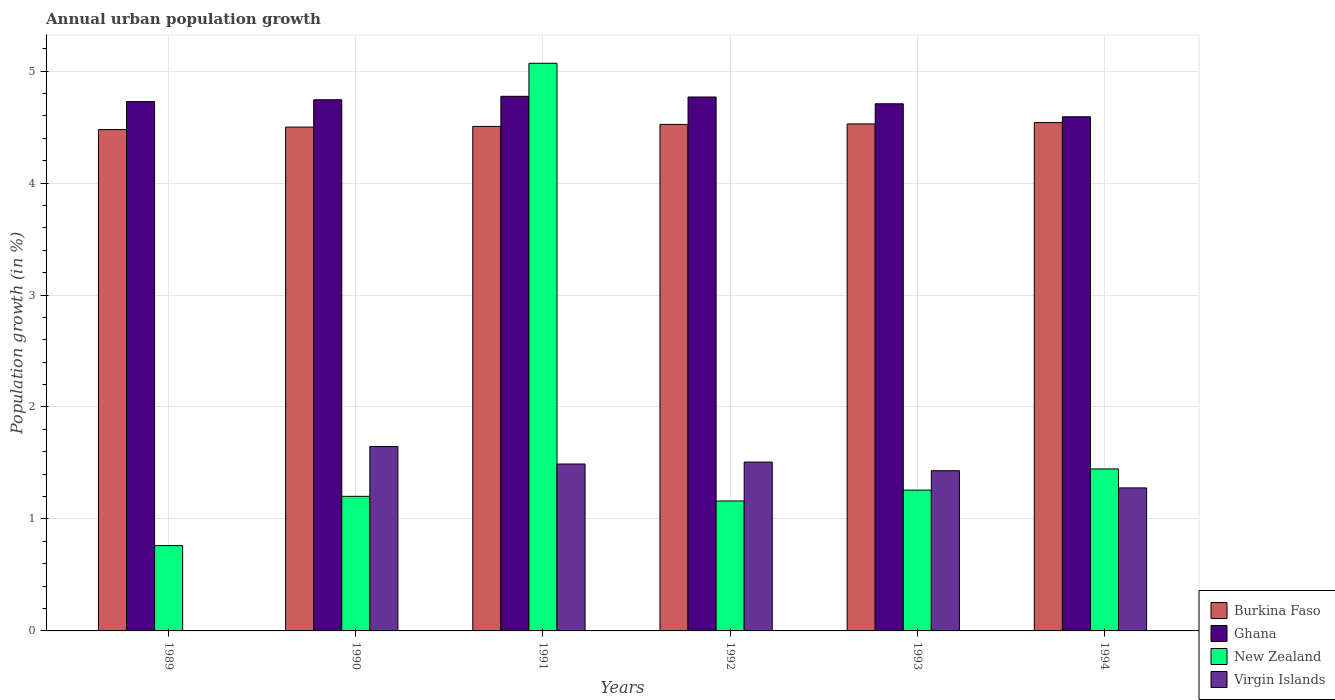How many different coloured bars are there?
Offer a very short reply. 4. How many groups of bars are there?
Provide a succinct answer. 6. How many bars are there on the 3rd tick from the right?
Offer a terse response. 4. What is the label of the 2nd group of bars from the left?
Offer a very short reply. 1990. In how many cases, is the number of bars for a given year not equal to the number of legend labels?
Provide a short and direct response. 1. What is the percentage of urban population growth in New Zealand in 1993?
Your answer should be very brief. 1.26. Across all years, what is the maximum percentage of urban population growth in Virgin Islands?
Your answer should be very brief. 1.65. Across all years, what is the minimum percentage of urban population growth in Burkina Faso?
Give a very brief answer. 4.48. What is the total percentage of urban population growth in Ghana in the graph?
Ensure brevity in your answer.  28.32. What is the difference between the percentage of urban population growth in Ghana in 1992 and that in 1994?
Offer a very short reply. 0.18. What is the difference between the percentage of urban population growth in Virgin Islands in 1994 and the percentage of urban population growth in Ghana in 1990?
Provide a succinct answer. -3.47. What is the average percentage of urban population growth in Ghana per year?
Provide a short and direct response. 4.72. In the year 1990, what is the difference between the percentage of urban population growth in Virgin Islands and percentage of urban population growth in Burkina Faso?
Provide a short and direct response. -2.85. What is the ratio of the percentage of urban population growth in New Zealand in 1989 to that in 1990?
Provide a succinct answer. 0.63. What is the difference between the highest and the second highest percentage of urban population growth in New Zealand?
Your answer should be very brief. 3.62. What is the difference between the highest and the lowest percentage of urban population growth in Virgin Islands?
Provide a short and direct response. 1.65. In how many years, is the percentage of urban population growth in New Zealand greater than the average percentage of urban population growth in New Zealand taken over all years?
Ensure brevity in your answer.  1. Is the sum of the percentage of urban population growth in Burkina Faso in 1993 and 1994 greater than the maximum percentage of urban population growth in Virgin Islands across all years?
Your answer should be compact. Yes. Is it the case that in every year, the sum of the percentage of urban population growth in Burkina Faso and percentage of urban population growth in Virgin Islands is greater than the sum of percentage of urban population growth in Ghana and percentage of urban population growth in New Zealand?
Provide a succinct answer. No. Are all the bars in the graph horizontal?
Your response must be concise. No. Where does the legend appear in the graph?
Your response must be concise. Bottom right. How many legend labels are there?
Your answer should be very brief. 4. How are the legend labels stacked?
Provide a succinct answer. Vertical. What is the title of the graph?
Give a very brief answer. Annual urban population growth. Does "Europe(all income levels)" appear as one of the legend labels in the graph?
Ensure brevity in your answer.  No. What is the label or title of the X-axis?
Your response must be concise. Years. What is the label or title of the Y-axis?
Make the answer very short. Population growth (in %). What is the Population growth (in %) of Burkina Faso in 1989?
Provide a short and direct response. 4.48. What is the Population growth (in %) of Ghana in 1989?
Your response must be concise. 4.73. What is the Population growth (in %) of New Zealand in 1989?
Ensure brevity in your answer.  0.76. What is the Population growth (in %) of Virgin Islands in 1989?
Provide a succinct answer. 0. What is the Population growth (in %) of Burkina Faso in 1990?
Offer a very short reply. 4.5. What is the Population growth (in %) of Ghana in 1990?
Give a very brief answer. 4.74. What is the Population growth (in %) in New Zealand in 1990?
Ensure brevity in your answer.  1.2. What is the Population growth (in %) of Virgin Islands in 1990?
Provide a succinct answer. 1.65. What is the Population growth (in %) of Burkina Faso in 1991?
Offer a very short reply. 4.51. What is the Population growth (in %) of Ghana in 1991?
Your response must be concise. 4.77. What is the Population growth (in %) of New Zealand in 1991?
Offer a very short reply. 5.07. What is the Population growth (in %) in Virgin Islands in 1991?
Keep it short and to the point. 1.49. What is the Population growth (in %) in Burkina Faso in 1992?
Provide a short and direct response. 4.52. What is the Population growth (in %) in Ghana in 1992?
Give a very brief answer. 4.77. What is the Population growth (in %) of New Zealand in 1992?
Offer a very short reply. 1.16. What is the Population growth (in %) in Virgin Islands in 1992?
Provide a short and direct response. 1.51. What is the Population growth (in %) of Burkina Faso in 1993?
Provide a succinct answer. 4.53. What is the Population growth (in %) of Ghana in 1993?
Offer a very short reply. 4.71. What is the Population growth (in %) in New Zealand in 1993?
Your response must be concise. 1.26. What is the Population growth (in %) of Virgin Islands in 1993?
Make the answer very short. 1.43. What is the Population growth (in %) in Burkina Faso in 1994?
Your answer should be compact. 4.54. What is the Population growth (in %) of Ghana in 1994?
Your answer should be very brief. 4.59. What is the Population growth (in %) of New Zealand in 1994?
Your answer should be compact. 1.45. What is the Population growth (in %) in Virgin Islands in 1994?
Make the answer very short. 1.28. Across all years, what is the maximum Population growth (in %) in Burkina Faso?
Ensure brevity in your answer.  4.54. Across all years, what is the maximum Population growth (in %) in Ghana?
Make the answer very short. 4.77. Across all years, what is the maximum Population growth (in %) in New Zealand?
Provide a succinct answer. 5.07. Across all years, what is the maximum Population growth (in %) in Virgin Islands?
Your response must be concise. 1.65. Across all years, what is the minimum Population growth (in %) in Burkina Faso?
Provide a succinct answer. 4.48. Across all years, what is the minimum Population growth (in %) in Ghana?
Your response must be concise. 4.59. Across all years, what is the minimum Population growth (in %) in New Zealand?
Ensure brevity in your answer.  0.76. What is the total Population growth (in %) of Burkina Faso in the graph?
Your answer should be very brief. 27.08. What is the total Population growth (in %) of Ghana in the graph?
Give a very brief answer. 28.32. What is the total Population growth (in %) in New Zealand in the graph?
Give a very brief answer. 10.9. What is the total Population growth (in %) of Virgin Islands in the graph?
Your response must be concise. 7.35. What is the difference between the Population growth (in %) of Burkina Faso in 1989 and that in 1990?
Ensure brevity in your answer.  -0.02. What is the difference between the Population growth (in %) in Ghana in 1989 and that in 1990?
Keep it short and to the point. -0.02. What is the difference between the Population growth (in %) in New Zealand in 1989 and that in 1990?
Make the answer very short. -0.44. What is the difference between the Population growth (in %) of Burkina Faso in 1989 and that in 1991?
Your response must be concise. -0.03. What is the difference between the Population growth (in %) of Ghana in 1989 and that in 1991?
Your answer should be very brief. -0.05. What is the difference between the Population growth (in %) of New Zealand in 1989 and that in 1991?
Give a very brief answer. -4.31. What is the difference between the Population growth (in %) in Burkina Faso in 1989 and that in 1992?
Give a very brief answer. -0.05. What is the difference between the Population growth (in %) in Ghana in 1989 and that in 1992?
Provide a succinct answer. -0.04. What is the difference between the Population growth (in %) in New Zealand in 1989 and that in 1992?
Offer a very short reply. -0.4. What is the difference between the Population growth (in %) of Burkina Faso in 1989 and that in 1993?
Your response must be concise. -0.05. What is the difference between the Population growth (in %) of Ghana in 1989 and that in 1993?
Offer a very short reply. 0.02. What is the difference between the Population growth (in %) in New Zealand in 1989 and that in 1993?
Make the answer very short. -0.5. What is the difference between the Population growth (in %) in Burkina Faso in 1989 and that in 1994?
Provide a short and direct response. -0.06. What is the difference between the Population growth (in %) in Ghana in 1989 and that in 1994?
Your answer should be compact. 0.14. What is the difference between the Population growth (in %) in New Zealand in 1989 and that in 1994?
Your answer should be compact. -0.68. What is the difference between the Population growth (in %) in Burkina Faso in 1990 and that in 1991?
Ensure brevity in your answer.  -0.01. What is the difference between the Population growth (in %) in Ghana in 1990 and that in 1991?
Provide a succinct answer. -0.03. What is the difference between the Population growth (in %) in New Zealand in 1990 and that in 1991?
Give a very brief answer. -3.87. What is the difference between the Population growth (in %) of Virgin Islands in 1990 and that in 1991?
Keep it short and to the point. 0.16. What is the difference between the Population growth (in %) in Burkina Faso in 1990 and that in 1992?
Give a very brief answer. -0.02. What is the difference between the Population growth (in %) in Ghana in 1990 and that in 1992?
Provide a short and direct response. -0.02. What is the difference between the Population growth (in %) in New Zealand in 1990 and that in 1992?
Give a very brief answer. 0.04. What is the difference between the Population growth (in %) in Virgin Islands in 1990 and that in 1992?
Give a very brief answer. 0.14. What is the difference between the Population growth (in %) of Burkina Faso in 1990 and that in 1993?
Make the answer very short. -0.03. What is the difference between the Population growth (in %) in Ghana in 1990 and that in 1993?
Offer a terse response. 0.04. What is the difference between the Population growth (in %) in New Zealand in 1990 and that in 1993?
Ensure brevity in your answer.  -0.06. What is the difference between the Population growth (in %) of Virgin Islands in 1990 and that in 1993?
Provide a succinct answer. 0.22. What is the difference between the Population growth (in %) in Burkina Faso in 1990 and that in 1994?
Provide a succinct answer. -0.04. What is the difference between the Population growth (in %) of Ghana in 1990 and that in 1994?
Provide a short and direct response. 0.15. What is the difference between the Population growth (in %) of New Zealand in 1990 and that in 1994?
Your response must be concise. -0.24. What is the difference between the Population growth (in %) in Virgin Islands in 1990 and that in 1994?
Ensure brevity in your answer.  0.37. What is the difference between the Population growth (in %) of Burkina Faso in 1991 and that in 1992?
Ensure brevity in your answer.  -0.02. What is the difference between the Population growth (in %) of Ghana in 1991 and that in 1992?
Offer a terse response. 0.01. What is the difference between the Population growth (in %) in New Zealand in 1991 and that in 1992?
Make the answer very short. 3.91. What is the difference between the Population growth (in %) of Virgin Islands in 1991 and that in 1992?
Your response must be concise. -0.02. What is the difference between the Population growth (in %) in Burkina Faso in 1991 and that in 1993?
Offer a terse response. -0.02. What is the difference between the Population growth (in %) of Ghana in 1991 and that in 1993?
Your answer should be very brief. 0.07. What is the difference between the Population growth (in %) in New Zealand in 1991 and that in 1993?
Offer a terse response. 3.81. What is the difference between the Population growth (in %) of Virgin Islands in 1991 and that in 1993?
Keep it short and to the point. 0.06. What is the difference between the Population growth (in %) in Burkina Faso in 1991 and that in 1994?
Give a very brief answer. -0.03. What is the difference between the Population growth (in %) of Ghana in 1991 and that in 1994?
Your response must be concise. 0.18. What is the difference between the Population growth (in %) in New Zealand in 1991 and that in 1994?
Offer a terse response. 3.62. What is the difference between the Population growth (in %) of Virgin Islands in 1991 and that in 1994?
Ensure brevity in your answer.  0.21. What is the difference between the Population growth (in %) of Burkina Faso in 1992 and that in 1993?
Your answer should be very brief. -0. What is the difference between the Population growth (in %) of Ghana in 1992 and that in 1993?
Your response must be concise. 0.06. What is the difference between the Population growth (in %) of New Zealand in 1992 and that in 1993?
Your response must be concise. -0.1. What is the difference between the Population growth (in %) in Virgin Islands in 1992 and that in 1993?
Offer a terse response. 0.08. What is the difference between the Population growth (in %) in Burkina Faso in 1992 and that in 1994?
Your response must be concise. -0.02. What is the difference between the Population growth (in %) in Ghana in 1992 and that in 1994?
Offer a very short reply. 0.18. What is the difference between the Population growth (in %) in New Zealand in 1992 and that in 1994?
Keep it short and to the point. -0.29. What is the difference between the Population growth (in %) in Virgin Islands in 1992 and that in 1994?
Your answer should be very brief. 0.23. What is the difference between the Population growth (in %) in Burkina Faso in 1993 and that in 1994?
Ensure brevity in your answer.  -0.01. What is the difference between the Population growth (in %) in Ghana in 1993 and that in 1994?
Provide a short and direct response. 0.12. What is the difference between the Population growth (in %) in New Zealand in 1993 and that in 1994?
Your answer should be very brief. -0.19. What is the difference between the Population growth (in %) in Virgin Islands in 1993 and that in 1994?
Make the answer very short. 0.15. What is the difference between the Population growth (in %) in Burkina Faso in 1989 and the Population growth (in %) in Ghana in 1990?
Your response must be concise. -0.27. What is the difference between the Population growth (in %) of Burkina Faso in 1989 and the Population growth (in %) of New Zealand in 1990?
Provide a short and direct response. 3.28. What is the difference between the Population growth (in %) in Burkina Faso in 1989 and the Population growth (in %) in Virgin Islands in 1990?
Offer a very short reply. 2.83. What is the difference between the Population growth (in %) in Ghana in 1989 and the Population growth (in %) in New Zealand in 1990?
Your answer should be very brief. 3.53. What is the difference between the Population growth (in %) of Ghana in 1989 and the Population growth (in %) of Virgin Islands in 1990?
Provide a succinct answer. 3.08. What is the difference between the Population growth (in %) in New Zealand in 1989 and the Population growth (in %) in Virgin Islands in 1990?
Your answer should be very brief. -0.88. What is the difference between the Population growth (in %) of Burkina Faso in 1989 and the Population growth (in %) of Ghana in 1991?
Ensure brevity in your answer.  -0.3. What is the difference between the Population growth (in %) in Burkina Faso in 1989 and the Population growth (in %) in New Zealand in 1991?
Offer a terse response. -0.59. What is the difference between the Population growth (in %) of Burkina Faso in 1989 and the Population growth (in %) of Virgin Islands in 1991?
Make the answer very short. 2.99. What is the difference between the Population growth (in %) of Ghana in 1989 and the Population growth (in %) of New Zealand in 1991?
Make the answer very short. -0.34. What is the difference between the Population growth (in %) of Ghana in 1989 and the Population growth (in %) of Virgin Islands in 1991?
Your answer should be compact. 3.24. What is the difference between the Population growth (in %) in New Zealand in 1989 and the Population growth (in %) in Virgin Islands in 1991?
Make the answer very short. -0.73. What is the difference between the Population growth (in %) of Burkina Faso in 1989 and the Population growth (in %) of Ghana in 1992?
Ensure brevity in your answer.  -0.29. What is the difference between the Population growth (in %) of Burkina Faso in 1989 and the Population growth (in %) of New Zealand in 1992?
Your answer should be compact. 3.32. What is the difference between the Population growth (in %) in Burkina Faso in 1989 and the Population growth (in %) in Virgin Islands in 1992?
Offer a terse response. 2.97. What is the difference between the Population growth (in %) in Ghana in 1989 and the Population growth (in %) in New Zealand in 1992?
Make the answer very short. 3.57. What is the difference between the Population growth (in %) of Ghana in 1989 and the Population growth (in %) of Virgin Islands in 1992?
Keep it short and to the point. 3.22. What is the difference between the Population growth (in %) in New Zealand in 1989 and the Population growth (in %) in Virgin Islands in 1992?
Your response must be concise. -0.75. What is the difference between the Population growth (in %) of Burkina Faso in 1989 and the Population growth (in %) of Ghana in 1993?
Offer a very short reply. -0.23. What is the difference between the Population growth (in %) in Burkina Faso in 1989 and the Population growth (in %) in New Zealand in 1993?
Offer a very short reply. 3.22. What is the difference between the Population growth (in %) in Burkina Faso in 1989 and the Population growth (in %) in Virgin Islands in 1993?
Provide a short and direct response. 3.05. What is the difference between the Population growth (in %) in Ghana in 1989 and the Population growth (in %) in New Zealand in 1993?
Give a very brief answer. 3.47. What is the difference between the Population growth (in %) in Ghana in 1989 and the Population growth (in %) in Virgin Islands in 1993?
Provide a short and direct response. 3.3. What is the difference between the Population growth (in %) in New Zealand in 1989 and the Population growth (in %) in Virgin Islands in 1993?
Your response must be concise. -0.67. What is the difference between the Population growth (in %) in Burkina Faso in 1989 and the Population growth (in %) in Ghana in 1994?
Provide a short and direct response. -0.11. What is the difference between the Population growth (in %) of Burkina Faso in 1989 and the Population growth (in %) of New Zealand in 1994?
Your response must be concise. 3.03. What is the difference between the Population growth (in %) in Burkina Faso in 1989 and the Population growth (in %) in Virgin Islands in 1994?
Make the answer very short. 3.2. What is the difference between the Population growth (in %) of Ghana in 1989 and the Population growth (in %) of New Zealand in 1994?
Provide a succinct answer. 3.28. What is the difference between the Population growth (in %) of Ghana in 1989 and the Population growth (in %) of Virgin Islands in 1994?
Offer a terse response. 3.45. What is the difference between the Population growth (in %) of New Zealand in 1989 and the Population growth (in %) of Virgin Islands in 1994?
Provide a short and direct response. -0.52. What is the difference between the Population growth (in %) of Burkina Faso in 1990 and the Population growth (in %) of Ghana in 1991?
Provide a succinct answer. -0.27. What is the difference between the Population growth (in %) in Burkina Faso in 1990 and the Population growth (in %) in New Zealand in 1991?
Offer a terse response. -0.57. What is the difference between the Population growth (in %) of Burkina Faso in 1990 and the Population growth (in %) of Virgin Islands in 1991?
Provide a short and direct response. 3.01. What is the difference between the Population growth (in %) of Ghana in 1990 and the Population growth (in %) of New Zealand in 1991?
Offer a terse response. -0.33. What is the difference between the Population growth (in %) of Ghana in 1990 and the Population growth (in %) of Virgin Islands in 1991?
Your response must be concise. 3.25. What is the difference between the Population growth (in %) in New Zealand in 1990 and the Population growth (in %) in Virgin Islands in 1991?
Make the answer very short. -0.29. What is the difference between the Population growth (in %) of Burkina Faso in 1990 and the Population growth (in %) of Ghana in 1992?
Offer a terse response. -0.27. What is the difference between the Population growth (in %) of Burkina Faso in 1990 and the Population growth (in %) of New Zealand in 1992?
Provide a succinct answer. 3.34. What is the difference between the Population growth (in %) of Burkina Faso in 1990 and the Population growth (in %) of Virgin Islands in 1992?
Your answer should be compact. 2.99. What is the difference between the Population growth (in %) of Ghana in 1990 and the Population growth (in %) of New Zealand in 1992?
Give a very brief answer. 3.58. What is the difference between the Population growth (in %) of Ghana in 1990 and the Population growth (in %) of Virgin Islands in 1992?
Provide a succinct answer. 3.24. What is the difference between the Population growth (in %) in New Zealand in 1990 and the Population growth (in %) in Virgin Islands in 1992?
Your response must be concise. -0.31. What is the difference between the Population growth (in %) of Burkina Faso in 1990 and the Population growth (in %) of Ghana in 1993?
Ensure brevity in your answer.  -0.21. What is the difference between the Population growth (in %) in Burkina Faso in 1990 and the Population growth (in %) in New Zealand in 1993?
Offer a very short reply. 3.24. What is the difference between the Population growth (in %) in Burkina Faso in 1990 and the Population growth (in %) in Virgin Islands in 1993?
Your answer should be very brief. 3.07. What is the difference between the Population growth (in %) in Ghana in 1990 and the Population growth (in %) in New Zealand in 1993?
Keep it short and to the point. 3.49. What is the difference between the Population growth (in %) of Ghana in 1990 and the Population growth (in %) of Virgin Islands in 1993?
Ensure brevity in your answer.  3.31. What is the difference between the Population growth (in %) in New Zealand in 1990 and the Population growth (in %) in Virgin Islands in 1993?
Give a very brief answer. -0.23. What is the difference between the Population growth (in %) in Burkina Faso in 1990 and the Population growth (in %) in Ghana in 1994?
Make the answer very short. -0.09. What is the difference between the Population growth (in %) in Burkina Faso in 1990 and the Population growth (in %) in New Zealand in 1994?
Provide a succinct answer. 3.05. What is the difference between the Population growth (in %) of Burkina Faso in 1990 and the Population growth (in %) of Virgin Islands in 1994?
Provide a succinct answer. 3.22. What is the difference between the Population growth (in %) in Ghana in 1990 and the Population growth (in %) in New Zealand in 1994?
Your answer should be very brief. 3.3. What is the difference between the Population growth (in %) of Ghana in 1990 and the Population growth (in %) of Virgin Islands in 1994?
Ensure brevity in your answer.  3.47. What is the difference between the Population growth (in %) in New Zealand in 1990 and the Population growth (in %) in Virgin Islands in 1994?
Your response must be concise. -0.08. What is the difference between the Population growth (in %) of Burkina Faso in 1991 and the Population growth (in %) of Ghana in 1992?
Provide a short and direct response. -0.26. What is the difference between the Population growth (in %) in Burkina Faso in 1991 and the Population growth (in %) in New Zealand in 1992?
Ensure brevity in your answer.  3.35. What is the difference between the Population growth (in %) of Burkina Faso in 1991 and the Population growth (in %) of Virgin Islands in 1992?
Ensure brevity in your answer.  3. What is the difference between the Population growth (in %) in Ghana in 1991 and the Population growth (in %) in New Zealand in 1992?
Your answer should be very brief. 3.61. What is the difference between the Population growth (in %) of Ghana in 1991 and the Population growth (in %) of Virgin Islands in 1992?
Provide a short and direct response. 3.27. What is the difference between the Population growth (in %) of New Zealand in 1991 and the Population growth (in %) of Virgin Islands in 1992?
Offer a very short reply. 3.56. What is the difference between the Population growth (in %) of Burkina Faso in 1991 and the Population growth (in %) of Ghana in 1993?
Keep it short and to the point. -0.2. What is the difference between the Population growth (in %) in Burkina Faso in 1991 and the Population growth (in %) in New Zealand in 1993?
Offer a very short reply. 3.25. What is the difference between the Population growth (in %) of Burkina Faso in 1991 and the Population growth (in %) of Virgin Islands in 1993?
Your response must be concise. 3.07. What is the difference between the Population growth (in %) in Ghana in 1991 and the Population growth (in %) in New Zealand in 1993?
Your answer should be compact. 3.52. What is the difference between the Population growth (in %) of Ghana in 1991 and the Population growth (in %) of Virgin Islands in 1993?
Your answer should be very brief. 3.34. What is the difference between the Population growth (in %) in New Zealand in 1991 and the Population growth (in %) in Virgin Islands in 1993?
Provide a succinct answer. 3.64. What is the difference between the Population growth (in %) in Burkina Faso in 1991 and the Population growth (in %) in Ghana in 1994?
Provide a succinct answer. -0.09. What is the difference between the Population growth (in %) in Burkina Faso in 1991 and the Population growth (in %) in New Zealand in 1994?
Keep it short and to the point. 3.06. What is the difference between the Population growth (in %) in Burkina Faso in 1991 and the Population growth (in %) in Virgin Islands in 1994?
Give a very brief answer. 3.23. What is the difference between the Population growth (in %) in Ghana in 1991 and the Population growth (in %) in New Zealand in 1994?
Your answer should be compact. 3.33. What is the difference between the Population growth (in %) in Ghana in 1991 and the Population growth (in %) in Virgin Islands in 1994?
Keep it short and to the point. 3.5. What is the difference between the Population growth (in %) of New Zealand in 1991 and the Population growth (in %) of Virgin Islands in 1994?
Ensure brevity in your answer.  3.79. What is the difference between the Population growth (in %) of Burkina Faso in 1992 and the Population growth (in %) of Ghana in 1993?
Ensure brevity in your answer.  -0.18. What is the difference between the Population growth (in %) of Burkina Faso in 1992 and the Population growth (in %) of New Zealand in 1993?
Provide a short and direct response. 3.27. What is the difference between the Population growth (in %) of Burkina Faso in 1992 and the Population growth (in %) of Virgin Islands in 1993?
Keep it short and to the point. 3.09. What is the difference between the Population growth (in %) of Ghana in 1992 and the Population growth (in %) of New Zealand in 1993?
Your response must be concise. 3.51. What is the difference between the Population growth (in %) in Ghana in 1992 and the Population growth (in %) in Virgin Islands in 1993?
Your response must be concise. 3.34. What is the difference between the Population growth (in %) of New Zealand in 1992 and the Population growth (in %) of Virgin Islands in 1993?
Give a very brief answer. -0.27. What is the difference between the Population growth (in %) of Burkina Faso in 1992 and the Population growth (in %) of Ghana in 1994?
Provide a succinct answer. -0.07. What is the difference between the Population growth (in %) of Burkina Faso in 1992 and the Population growth (in %) of New Zealand in 1994?
Offer a terse response. 3.08. What is the difference between the Population growth (in %) in Burkina Faso in 1992 and the Population growth (in %) in Virgin Islands in 1994?
Provide a succinct answer. 3.25. What is the difference between the Population growth (in %) of Ghana in 1992 and the Population growth (in %) of New Zealand in 1994?
Make the answer very short. 3.32. What is the difference between the Population growth (in %) in Ghana in 1992 and the Population growth (in %) in Virgin Islands in 1994?
Your response must be concise. 3.49. What is the difference between the Population growth (in %) in New Zealand in 1992 and the Population growth (in %) in Virgin Islands in 1994?
Offer a very short reply. -0.12. What is the difference between the Population growth (in %) in Burkina Faso in 1993 and the Population growth (in %) in Ghana in 1994?
Your response must be concise. -0.06. What is the difference between the Population growth (in %) in Burkina Faso in 1993 and the Population growth (in %) in New Zealand in 1994?
Offer a very short reply. 3.08. What is the difference between the Population growth (in %) of Burkina Faso in 1993 and the Population growth (in %) of Virgin Islands in 1994?
Your answer should be compact. 3.25. What is the difference between the Population growth (in %) of Ghana in 1993 and the Population growth (in %) of New Zealand in 1994?
Make the answer very short. 3.26. What is the difference between the Population growth (in %) of Ghana in 1993 and the Population growth (in %) of Virgin Islands in 1994?
Your answer should be very brief. 3.43. What is the difference between the Population growth (in %) of New Zealand in 1993 and the Population growth (in %) of Virgin Islands in 1994?
Give a very brief answer. -0.02. What is the average Population growth (in %) of Burkina Faso per year?
Ensure brevity in your answer.  4.51. What is the average Population growth (in %) of Ghana per year?
Offer a very short reply. 4.72. What is the average Population growth (in %) in New Zealand per year?
Make the answer very short. 1.82. What is the average Population growth (in %) in Virgin Islands per year?
Ensure brevity in your answer.  1.23. In the year 1989, what is the difference between the Population growth (in %) in Burkina Faso and Population growth (in %) in Ghana?
Offer a very short reply. -0.25. In the year 1989, what is the difference between the Population growth (in %) of Burkina Faso and Population growth (in %) of New Zealand?
Keep it short and to the point. 3.72. In the year 1989, what is the difference between the Population growth (in %) of Ghana and Population growth (in %) of New Zealand?
Provide a succinct answer. 3.97. In the year 1990, what is the difference between the Population growth (in %) in Burkina Faso and Population growth (in %) in Ghana?
Provide a short and direct response. -0.24. In the year 1990, what is the difference between the Population growth (in %) of Burkina Faso and Population growth (in %) of New Zealand?
Provide a short and direct response. 3.3. In the year 1990, what is the difference between the Population growth (in %) of Burkina Faso and Population growth (in %) of Virgin Islands?
Keep it short and to the point. 2.85. In the year 1990, what is the difference between the Population growth (in %) in Ghana and Population growth (in %) in New Zealand?
Your response must be concise. 3.54. In the year 1990, what is the difference between the Population growth (in %) of Ghana and Population growth (in %) of Virgin Islands?
Provide a short and direct response. 3.1. In the year 1990, what is the difference between the Population growth (in %) in New Zealand and Population growth (in %) in Virgin Islands?
Offer a very short reply. -0.44. In the year 1991, what is the difference between the Population growth (in %) of Burkina Faso and Population growth (in %) of Ghana?
Give a very brief answer. -0.27. In the year 1991, what is the difference between the Population growth (in %) of Burkina Faso and Population growth (in %) of New Zealand?
Offer a very short reply. -0.56. In the year 1991, what is the difference between the Population growth (in %) in Burkina Faso and Population growth (in %) in Virgin Islands?
Give a very brief answer. 3.02. In the year 1991, what is the difference between the Population growth (in %) of Ghana and Population growth (in %) of New Zealand?
Offer a terse response. -0.3. In the year 1991, what is the difference between the Population growth (in %) of Ghana and Population growth (in %) of Virgin Islands?
Provide a succinct answer. 3.28. In the year 1991, what is the difference between the Population growth (in %) of New Zealand and Population growth (in %) of Virgin Islands?
Your answer should be compact. 3.58. In the year 1992, what is the difference between the Population growth (in %) of Burkina Faso and Population growth (in %) of Ghana?
Your answer should be very brief. -0.24. In the year 1992, what is the difference between the Population growth (in %) in Burkina Faso and Population growth (in %) in New Zealand?
Your response must be concise. 3.36. In the year 1992, what is the difference between the Population growth (in %) of Burkina Faso and Population growth (in %) of Virgin Islands?
Ensure brevity in your answer.  3.02. In the year 1992, what is the difference between the Population growth (in %) of Ghana and Population growth (in %) of New Zealand?
Your answer should be very brief. 3.61. In the year 1992, what is the difference between the Population growth (in %) in Ghana and Population growth (in %) in Virgin Islands?
Offer a very short reply. 3.26. In the year 1992, what is the difference between the Population growth (in %) in New Zealand and Population growth (in %) in Virgin Islands?
Give a very brief answer. -0.35. In the year 1993, what is the difference between the Population growth (in %) in Burkina Faso and Population growth (in %) in Ghana?
Make the answer very short. -0.18. In the year 1993, what is the difference between the Population growth (in %) in Burkina Faso and Population growth (in %) in New Zealand?
Offer a terse response. 3.27. In the year 1993, what is the difference between the Population growth (in %) of Burkina Faso and Population growth (in %) of Virgin Islands?
Your response must be concise. 3.1. In the year 1993, what is the difference between the Population growth (in %) of Ghana and Population growth (in %) of New Zealand?
Keep it short and to the point. 3.45. In the year 1993, what is the difference between the Population growth (in %) of Ghana and Population growth (in %) of Virgin Islands?
Offer a very short reply. 3.28. In the year 1993, what is the difference between the Population growth (in %) of New Zealand and Population growth (in %) of Virgin Islands?
Your response must be concise. -0.17. In the year 1994, what is the difference between the Population growth (in %) in Burkina Faso and Population growth (in %) in Ghana?
Give a very brief answer. -0.05. In the year 1994, what is the difference between the Population growth (in %) of Burkina Faso and Population growth (in %) of New Zealand?
Offer a terse response. 3.09. In the year 1994, what is the difference between the Population growth (in %) in Burkina Faso and Population growth (in %) in Virgin Islands?
Offer a terse response. 3.26. In the year 1994, what is the difference between the Population growth (in %) of Ghana and Population growth (in %) of New Zealand?
Ensure brevity in your answer.  3.15. In the year 1994, what is the difference between the Population growth (in %) in Ghana and Population growth (in %) in Virgin Islands?
Your answer should be very brief. 3.31. In the year 1994, what is the difference between the Population growth (in %) of New Zealand and Population growth (in %) of Virgin Islands?
Offer a very short reply. 0.17. What is the ratio of the Population growth (in %) in New Zealand in 1989 to that in 1990?
Provide a succinct answer. 0.63. What is the ratio of the Population growth (in %) in Burkina Faso in 1989 to that in 1991?
Offer a terse response. 0.99. What is the ratio of the Population growth (in %) in Ghana in 1989 to that in 1991?
Your response must be concise. 0.99. What is the ratio of the Population growth (in %) of New Zealand in 1989 to that in 1991?
Make the answer very short. 0.15. What is the ratio of the Population growth (in %) of Ghana in 1989 to that in 1992?
Offer a very short reply. 0.99. What is the ratio of the Population growth (in %) of New Zealand in 1989 to that in 1992?
Your response must be concise. 0.66. What is the ratio of the Population growth (in %) of Burkina Faso in 1989 to that in 1993?
Provide a short and direct response. 0.99. What is the ratio of the Population growth (in %) in Ghana in 1989 to that in 1993?
Give a very brief answer. 1. What is the ratio of the Population growth (in %) in New Zealand in 1989 to that in 1993?
Give a very brief answer. 0.61. What is the ratio of the Population growth (in %) of Burkina Faso in 1989 to that in 1994?
Provide a short and direct response. 0.99. What is the ratio of the Population growth (in %) of Ghana in 1989 to that in 1994?
Your response must be concise. 1.03. What is the ratio of the Population growth (in %) in New Zealand in 1989 to that in 1994?
Ensure brevity in your answer.  0.53. What is the ratio of the Population growth (in %) in Burkina Faso in 1990 to that in 1991?
Your answer should be very brief. 1. What is the ratio of the Population growth (in %) in Ghana in 1990 to that in 1991?
Offer a very short reply. 0.99. What is the ratio of the Population growth (in %) of New Zealand in 1990 to that in 1991?
Make the answer very short. 0.24. What is the ratio of the Population growth (in %) of Virgin Islands in 1990 to that in 1991?
Provide a succinct answer. 1.1. What is the ratio of the Population growth (in %) of Burkina Faso in 1990 to that in 1992?
Provide a succinct answer. 0.99. What is the ratio of the Population growth (in %) in New Zealand in 1990 to that in 1992?
Offer a terse response. 1.04. What is the ratio of the Population growth (in %) of Virgin Islands in 1990 to that in 1992?
Give a very brief answer. 1.09. What is the ratio of the Population growth (in %) in Burkina Faso in 1990 to that in 1993?
Your answer should be very brief. 0.99. What is the ratio of the Population growth (in %) of Ghana in 1990 to that in 1993?
Make the answer very short. 1.01. What is the ratio of the Population growth (in %) in New Zealand in 1990 to that in 1993?
Make the answer very short. 0.96. What is the ratio of the Population growth (in %) of Virgin Islands in 1990 to that in 1993?
Your response must be concise. 1.15. What is the ratio of the Population growth (in %) of Ghana in 1990 to that in 1994?
Your response must be concise. 1.03. What is the ratio of the Population growth (in %) of New Zealand in 1990 to that in 1994?
Give a very brief answer. 0.83. What is the ratio of the Population growth (in %) of Virgin Islands in 1990 to that in 1994?
Your response must be concise. 1.29. What is the ratio of the Population growth (in %) of Burkina Faso in 1991 to that in 1992?
Provide a short and direct response. 1. What is the ratio of the Population growth (in %) of New Zealand in 1991 to that in 1992?
Your answer should be very brief. 4.37. What is the ratio of the Population growth (in %) of Virgin Islands in 1991 to that in 1992?
Provide a succinct answer. 0.99. What is the ratio of the Population growth (in %) in Burkina Faso in 1991 to that in 1993?
Your response must be concise. 1. What is the ratio of the Population growth (in %) of Ghana in 1991 to that in 1993?
Ensure brevity in your answer.  1.01. What is the ratio of the Population growth (in %) in New Zealand in 1991 to that in 1993?
Ensure brevity in your answer.  4.03. What is the ratio of the Population growth (in %) of Virgin Islands in 1991 to that in 1993?
Provide a succinct answer. 1.04. What is the ratio of the Population growth (in %) of Ghana in 1991 to that in 1994?
Your answer should be compact. 1.04. What is the ratio of the Population growth (in %) in New Zealand in 1991 to that in 1994?
Offer a terse response. 3.5. What is the ratio of the Population growth (in %) in Virgin Islands in 1991 to that in 1994?
Offer a terse response. 1.17. What is the ratio of the Population growth (in %) of Burkina Faso in 1992 to that in 1993?
Your answer should be very brief. 1. What is the ratio of the Population growth (in %) in Ghana in 1992 to that in 1993?
Provide a succinct answer. 1.01. What is the ratio of the Population growth (in %) in New Zealand in 1992 to that in 1993?
Your answer should be very brief. 0.92. What is the ratio of the Population growth (in %) in Virgin Islands in 1992 to that in 1993?
Provide a succinct answer. 1.05. What is the ratio of the Population growth (in %) in Burkina Faso in 1992 to that in 1994?
Offer a terse response. 1. What is the ratio of the Population growth (in %) in Ghana in 1992 to that in 1994?
Offer a very short reply. 1.04. What is the ratio of the Population growth (in %) in New Zealand in 1992 to that in 1994?
Offer a very short reply. 0.8. What is the ratio of the Population growth (in %) in Virgin Islands in 1992 to that in 1994?
Your response must be concise. 1.18. What is the ratio of the Population growth (in %) of Burkina Faso in 1993 to that in 1994?
Your response must be concise. 1. What is the ratio of the Population growth (in %) in Ghana in 1993 to that in 1994?
Your answer should be compact. 1.03. What is the ratio of the Population growth (in %) in New Zealand in 1993 to that in 1994?
Make the answer very short. 0.87. What is the ratio of the Population growth (in %) of Virgin Islands in 1993 to that in 1994?
Your answer should be compact. 1.12. What is the difference between the highest and the second highest Population growth (in %) in Burkina Faso?
Provide a succinct answer. 0.01. What is the difference between the highest and the second highest Population growth (in %) of Ghana?
Your answer should be compact. 0.01. What is the difference between the highest and the second highest Population growth (in %) in New Zealand?
Your answer should be compact. 3.62. What is the difference between the highest and the second highest Population growth (in %) of Virgin Islands?
Ensure brevity in your answer.  0.14. What is the difference between the highest and the lowest Population growth (in %) in Burkina Faso?
Your answer should be very brief. 0.06. What is the difference between the highest and the lowest Population growth (in %) of Ghana?
Offer a very short reply. 0.18. What is the difference between the highest and the lowest Population growth (in %) of New Zealand?
Provide a short and direct response. 4.31. What is the difference between the highest and the lowest Population growth (in %) in Virgin Islands?
Your answer should be very brief. 1.65. 